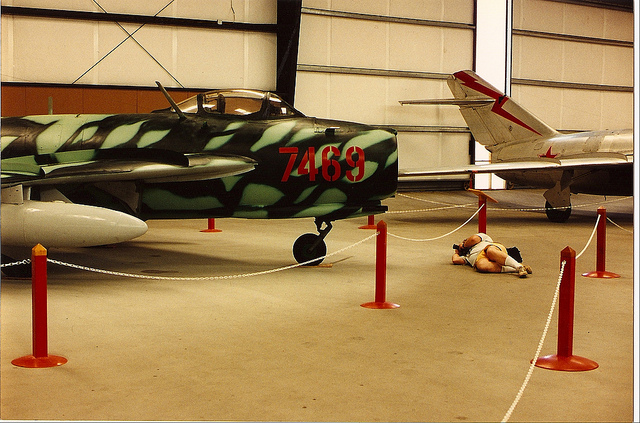Identify the text contained in this image. 7469 